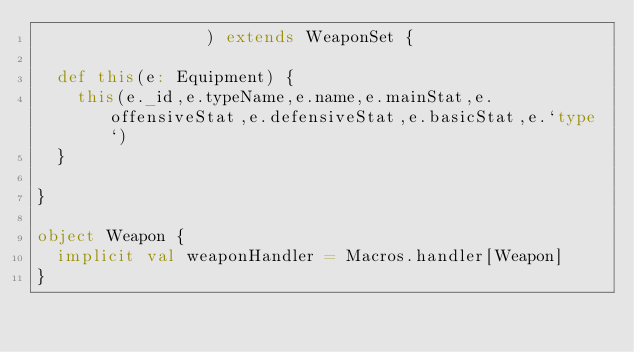<code> <loc_0><loc_0><loc_500><loc_500><_Scala_>                 ) extends WeaponSet {

  def this(e: Equipment) {
    this(e._id,e.typeName,e.name,e.mainStat,e.offensiveStat,e.defensiveStat,e.basicStat,e.`type`)
  }

}

object Weapon {
  implicit val weaponHandler = Macros.handler[Weapon]
}</code> 